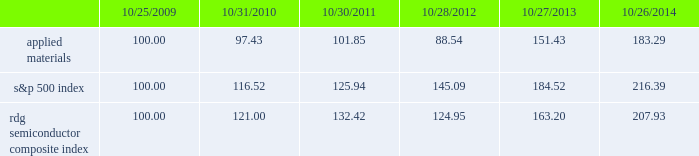Performance graph the performance graph below shows the five-year cumulative total stockholder return on applied common stock during the period from october 25 , 2009 through october 26 , 2014 .
This is compared with the cumulative total return of the standard & poor 2019s 500 stock index and the rdg semiconductor composite index over the same period .
The comparison assumes $ 100 was invested on october 25 , 2009 in applied common stock and in each of the foregoing indices and assumes reinvestment of dividends , if any .
Dollar amounts in the graph are rounded to the nearest whole dollar .
The performance shown in the graph represents past performance and should not be considered an indication of future performance .
Comparison of 5 year cumulative total return* among applied materials , inc. , the s&p 500 index 201cs&p 201d is a registered trademark of standard & poor 2019s financial services llc , a subsidiary of the mcgraw-hill companies , inc. .
Dividends during fiscal 2014 , applied 2019s board of directors declared four quarterly cash dividends of $ 0.10 per share each .
During fiscal 2013 , applied 2019s board of directors declared three quarterly cash dividends of $ 0.10 per share each and one quarterly cash dividend of $ 0.09 per share .
During fiscal 2012 , applied 2019s board of directors declared three quarterly cash dividends of $ 0.09 per share each and one quarterly cash dividend of $ 0.08 .
Dividends declared during fiscal 2014 , 2013 and 2012 totaled $ 487 million , $ 469 million and $ 438 million , respectively .
Applied currently anticipates that it will continue to pay cash dividends on a quarterly basis in the future , although the declaration and amount of any future cash dividends are at the discretion of the board of directors and will depend on applied 2019s financial condition , results of operations , capital requirements , business conditions and other factors , as well as a determination that cash dividends are in the best interests of applied 2019s stockholders .
$ 100 invested on 10/25/09 in stock or 10/31/09 in index , including reinvestment of dividends .
Indexes calculated on month-end basis .
And the rdg semiconductor composite index 183145 97 102 121 132 10/25/09 10/31/10 10/30/11 10/28/12 10/27/13 10/26/14 applied materials , inc .
S&p 500 rdg semiconductor composite .
What is the return on investment for applied materials if the investment occurred in 2009 and it is liquidated in 2012? 
Computations: ((88.54 - 100) / 100)
Answer: -0.1146. 